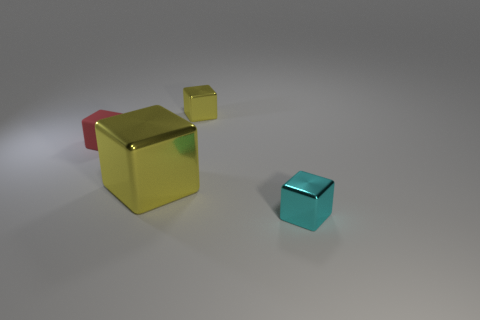Add 3 big shiny things. How many objects exist? 7 Add 1 red rubber cylinders. How many red rubber cylinders exist? 1 Subtract 0 green cylinders. How many objects are left? 4 Subtract all small cyan metal cubes. Subtract all cyan metallic cubes. How many objects are left? 2 Add 1 cyan metal cubes. How many cyan metal cubes are left? 2 